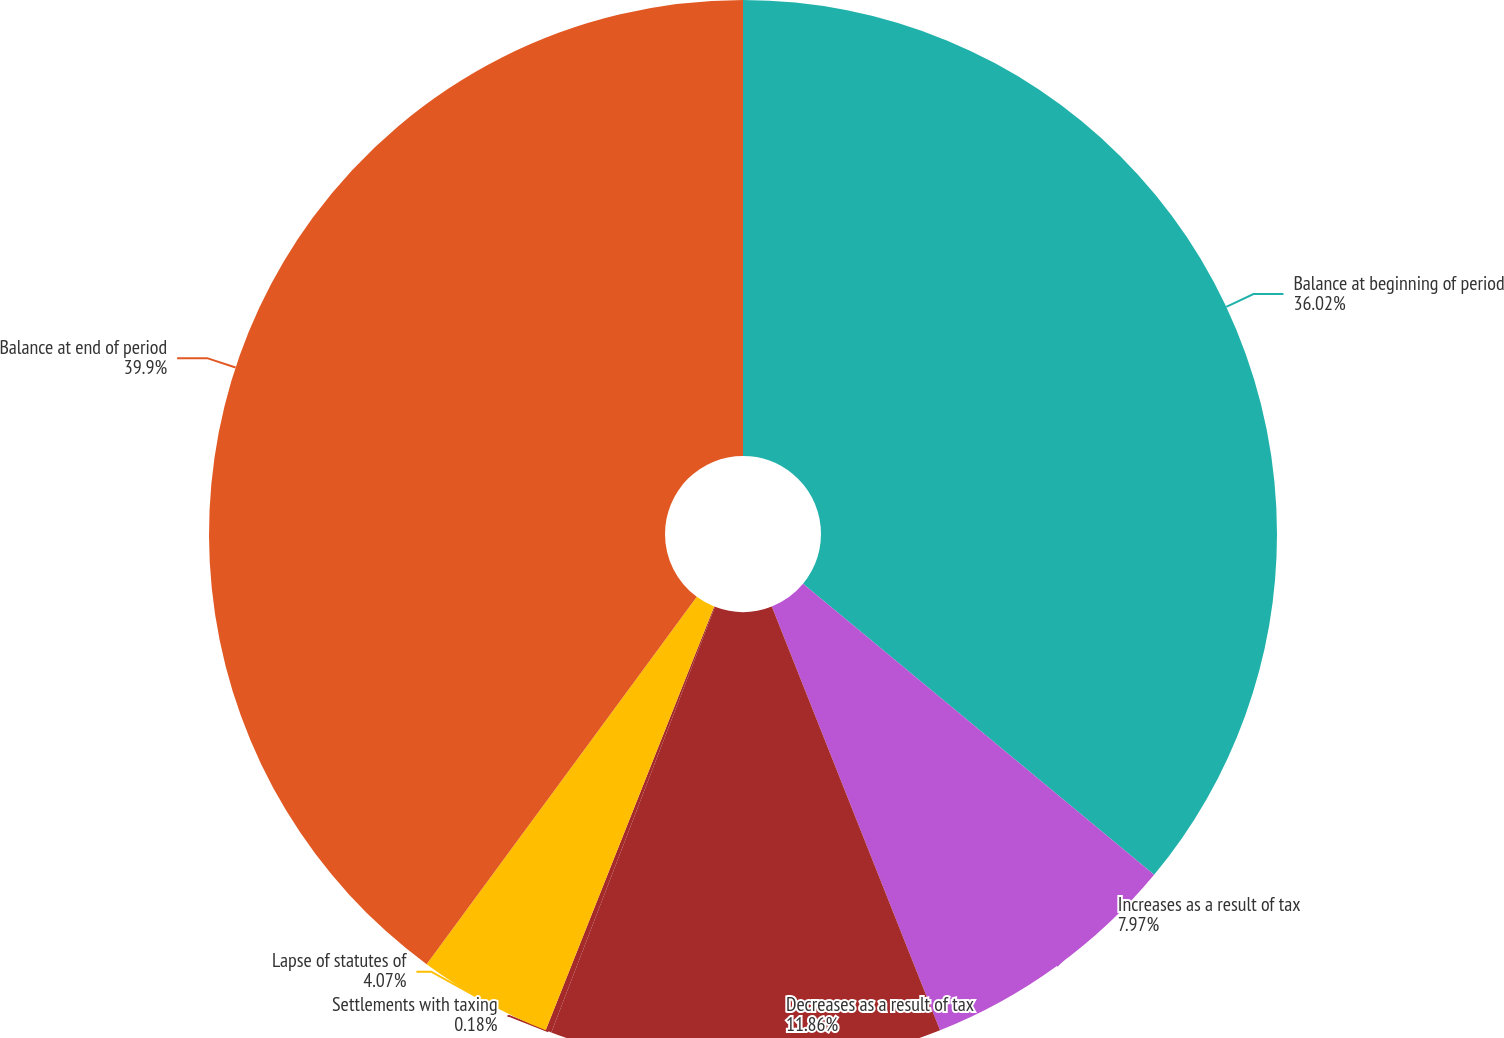Convert chart to OTSL. <chart><loc_0><loc_0><loc_500><loc_500><pie_chart><fcel>Balance at beginning of period<fcel>Increases as a result of tax<fcel>Decreases as a result of tax<fcel>Settlements with taxing<fcel>Lapse of statutes of<fcel>Balance at end of period<nl><fcel>36.02%<fcel>7.97%<fcel>11.86%<fcel>0.18%<fcel>4.07%<fcel>39.91%<nl></chart> 